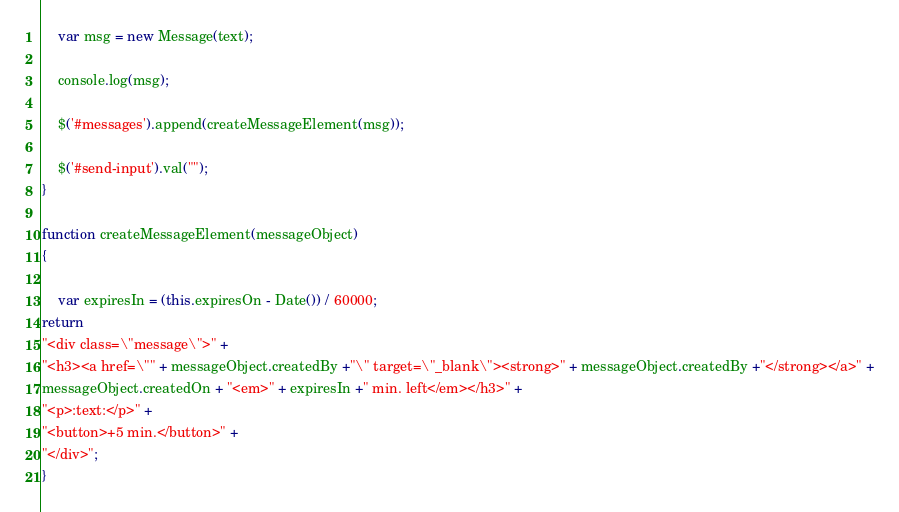<code> <loc_0><loc_0><loc_500><loc_500><_JavaScript_>
    var msg = new Message(text);

    console.log(msg);

    $('#messages').append(createMessageElement(msg));

    $('#send-input').val("");
}

function createMessageElement(messageObject) 
{

    var expiresIn = (this.expiresOn - Date()) / 60000;
return
"<div class=\"message\">" +
"<h3><a href=\"" + messageObject.createdBy +"\" target=\"_blank\"><strong>" + messageObject.createdBy +"</strong></a>" +
messageObject.createdOn + "<em>" + expiresIn +" min. left</em></h3>" +
"<p>:text:</p>" +
"<button>+5 min.</button>" +
"</div>";
}</code> 